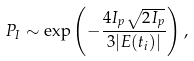<formula> <loc_0><loc_0><loc_500><loc_500>P _ { I } \sim \exp \left ( - \frac { 4 I _ { p } \sqrt { 2 I _ { p } } } { 3 | E ( t _ { i } ) | } \right ) ,</formula> 